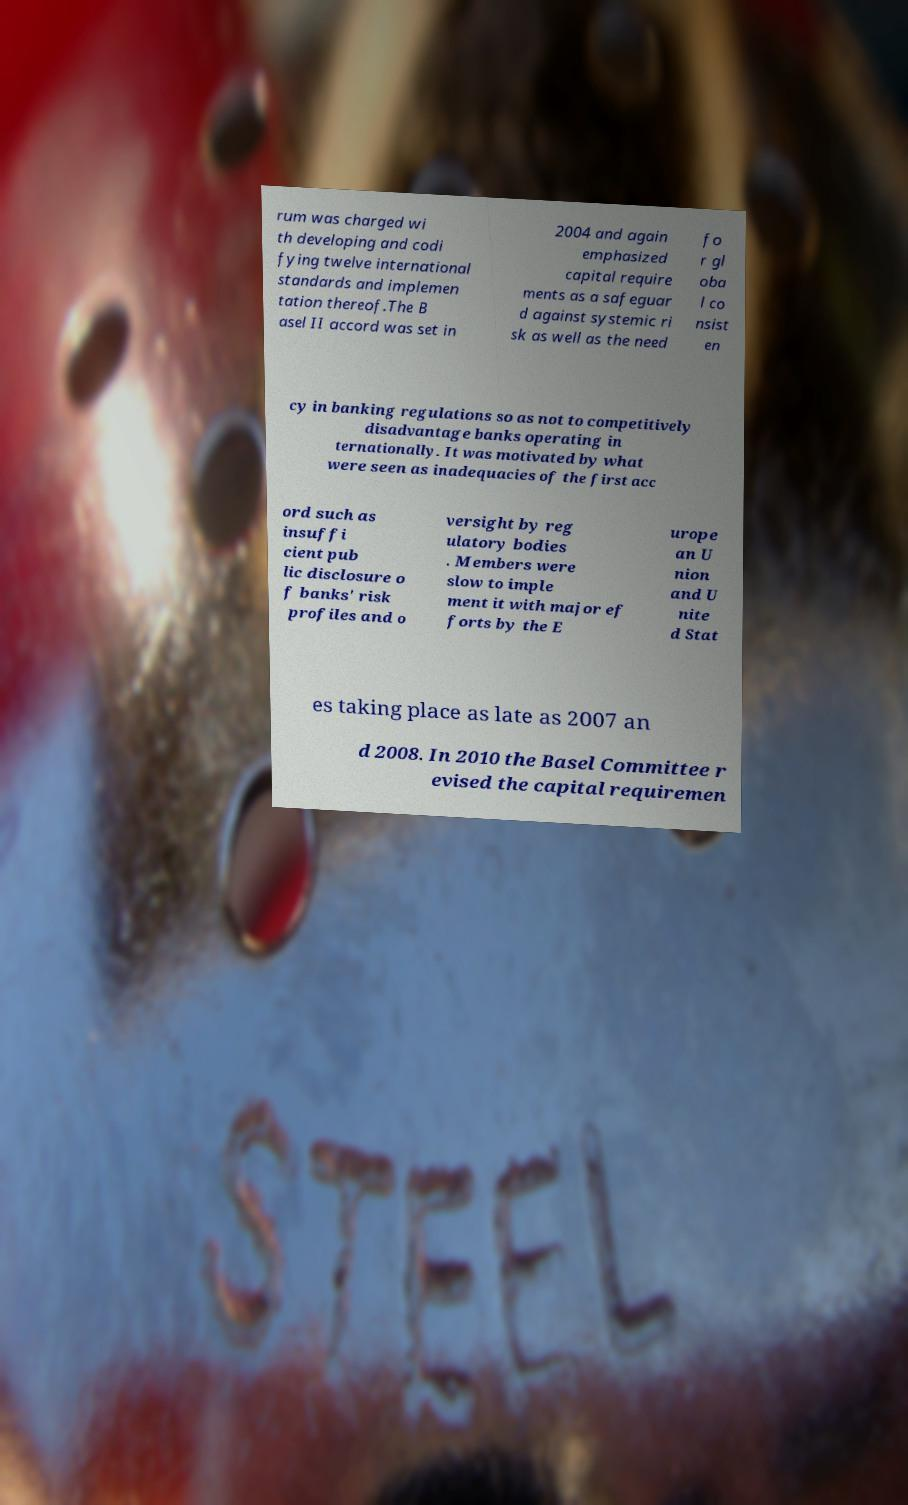Can you read and provide the text displayed in the image?This photo seems to have some interesting text. Can you extract and type it out for me? rum was charged wi th developing and codi fying twelve international standards and implemen tation thereof.The B asel II accord was set in 2004 and again emphasized capital require ments as a safeguar d against systemic ri sk as well as the need fo r gl oba l co nsist en cy in banking regulations so as not to competitively disadvantage banks operating in ternationally. It was motivated by what were seen as inadequacies of the first acc ord such as insuffi cient pub lic disclosure o f banks' risk profiles and o versight by reg ulatory bodies . Members were slow to imple ment it with major ef forts by the E urope an U nion and U nite d Stat es taking place as late as 2007 an d 2008. In 2010 the Basel Committee r evised the capital requiremen 